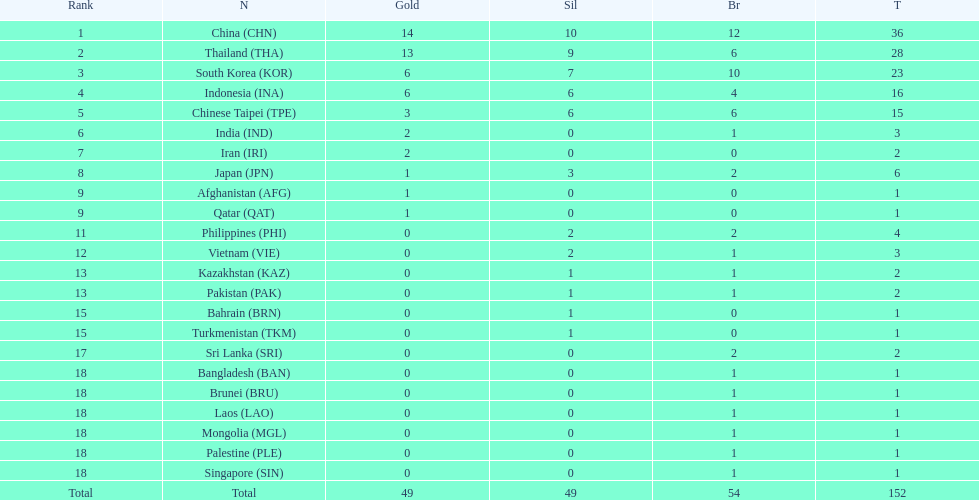What is the total number of nations that participated in the beach games of 2012? 23. 